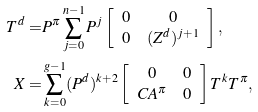<formula> <loc_0><loc_0><loc_500><loc_500>T ^ { d } = & P ^ { \pi } \sum _ { j = 0 } ^ { n - 1 } P ^ { j } \left [ \begin{array} { c c } 0 & 0 \\ 0 & ( Z ^ { d } ) ^ { j + 1 } \end{array} \right ] , \\ X = & \sum _ { k = 0 } ^ { g - 1 } ( P ^ { d } ) ^ { k + 2 } \left [ \begin{array} { c c } 0 & 0 \\ C A ^ { \pi } & 0 \end{array} \right ] T ^ { k } T ^ { \pi } , \\</formula> 